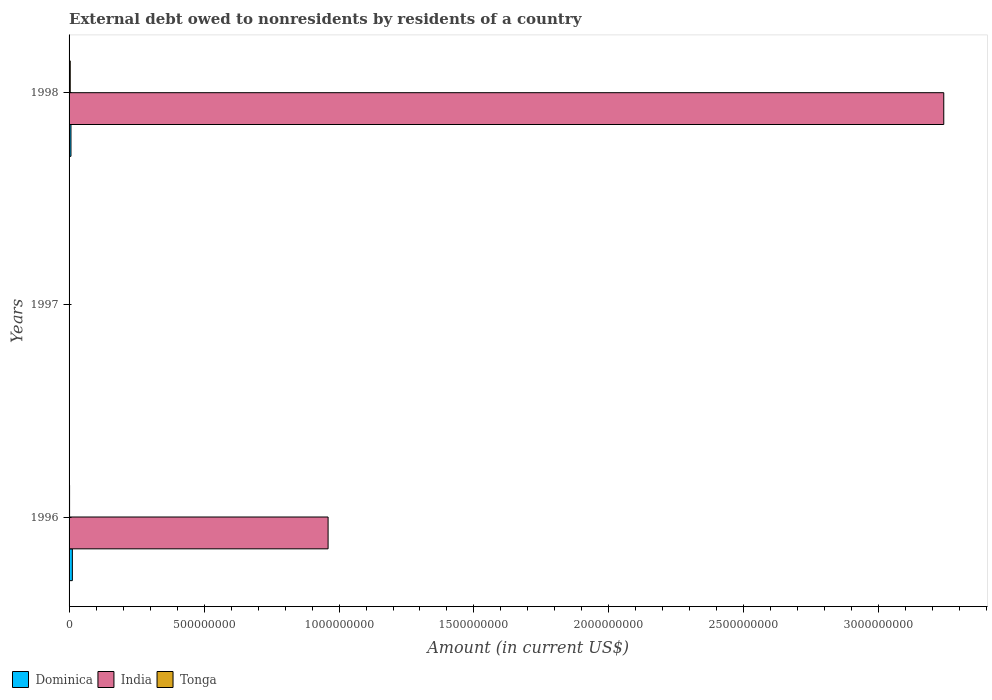How many different coloured bars are there?
Provide a short and direct response. 3. Are the number of bars on each tick of the Y-axis equal?
Provide a succinct answer. No. How many bars are there on the 1st tick from the bottom?
Keep it short and to the point. 3. In how many cases, is the number of bars for a given year not equal to the number of legend labels?
Provide a succinct answer. 1. What is the external debt owed by residents in India in 1996?
Give a very brief answer. 9.60e+08. Across all years, what is the maximum external debt owed by residents in Dominica?
Ensure brevity in your answer.  1.22e+07. Across all years, what is the minimum external debt owed by residents in India?
Provide a succinct answer. 0. In which year was the external debt owed by residents in Tonga maximum?
Ensure brevity in your answer.  1998. What is the total external debt owed by residents in Dominica in the graph?
Offer a terse response. 1.92e+07. What is the difference between the external debt owed by residents in Tonga in 1997 and that in 1998?
Your answer should be compact. -3.48e+06. What is the difference between the external debt owed by residents in Tonga in 1998 and the external debt owed by residents in India in 1997?
Make the answer very short. 4.29e+06. What is the average external debt owed by residents in Dominica per year?
Your response must be concise. 6.41e+06. In the year 1998, what is the difference between the external debt owed by residents in Dominica and external debt owed by residents in Tonga?
Your response must be concise. 2.77e+06. What is the ratio of the external debt owed by residents in Tonga in 1996 to that in 1998?
Provide a succinct answer. 0.43. Is the external debt owed by residents in Tonga in 1996 less than that in 1998?
Give a very brief answer. Yes. What is the difference between the highest and the second highest external debt owed by residents in Tonga?
Provide a short and direct response. 2.42e+06. What is the difference between the highest and the lowest external debt owed by residents in Dominica?
Your answer should be compact. 1.22e+07. In how many years, is the external debt owed by residents in Dominica greater than the average external debt owed by residents in Dominica taken over all years?
Give a very brief answer. 2. Is the sum of the external debt owed by residents in India in 1996 and 1998 greater than the maximum external debt owed by residents in Dominica across all years?
Provide a succinct answer. Yes. Is it the case that in every year, the sum of the external debt owed by residents in Dominica and external debt owed by residents in Tonga is greater than the external debt owed by residents in India?
Give a very brief answer. No. How many years are there in the graph?
Ensure brevity in your answer.  3. What is the difference between two consecutive major ticks on the X-axis?
Your answer should be compact. 5.00e+08. Where does the legend appear in the graph?
Offer a terse response. Bottom left. How many legend labels are there?
Make the answer very short. 3. How are the legend labels stacked?
Offer a very short reply. Horizontal. What is the title of the graph?
Provide a short and direct response. External debt owed to nonresidents by residents of a country. Does "Trinidad and Tobago" appear as one of the legend labels in the graph?
Offer a terse response. No. What is the label or title of the X-axis?
Provide a short and direct response. Amount (in current US$). What is the Amount (in current US$) of Dominica in 1996?
Provide a short and direct response. 1.22e+07. What is the Amount (in current US$) in India in 1996?
Offer a very short reply. 9.60e+08. What is the Amount (in current US$) of Tonga in 1996?
Offer a very short reply. 1.86e+06. What is the Amount (in current US$) of Dominica in 1997?
Offer a terse response. 0. What is the Amount (in current US$) in Tonga in 1997?
Your answer should be very brief. 8.12e+05. What is the Amount (in current US$) in Dominica in 1998?
Ensure brevity in your answer.  7.06e+06. What is the Amount (in current US$) in India in 1998?
Make the answer very short. 3.24e+09. What is the Amount (in current US$) of Tonga in 1998?
Ensure brevity in your answer.  4.29e+06. Across all years, what is the maximum Amount (in current US$) in Dominica?
Keep it short and to the point. 1.22e+07. Across all years, what is the maximum Amount (in current US$) of India?
Offer a terse response. 3.24e+09. Across all years, what is the maximum Amount (in current US$) in Tonga?
Your response must be concise. 4.29e+06. Across all years, what is the minimum Amount (in current US$) in Dominica?
Offer a very short reply. 0. Across all years, what is the minimum Amount (in current US$) of Tonga?
Offer a very short reply. 8.12e+05. What is the total Amount (in current US$) in Dominica in the graph?
Your answer should be compact. 1.92e+07. What is the total Amount (in current US$) in India in the graph?
Provide a succinct answer. 4.20e+09. What is the total Amount (in current US$) in Tonga in the graph?
Offer a terse response. 6.97e+06. What is the difference between the Amount (in current US$) in Tonga in 1996 and that in 1997?
Keep it short and to the point. 1.05e+06. What is the difference between the Amount (in current US$) of Dominica in 1996 and that in 1998?
Give a very brief answer. 5.13e+06. What is the difference between the Amount (in current US$) of India in 1996 and that in 1998?
Your answer should be very brief. -2.28e+09. What is the difference between the Amount (in current US$) of Tonga in 1996 and that in 1998?
Ensure brevity in your answer.  -2.42e+06. What is the difference between the Amount (in current US$) in Tonga in 1997 and that in 1998?
Provide a succinct answer. -3.48e+06. What is the difference between the Amount (in current US$) in Dominica in 1996 and the Amount (in current US$) in Tonga in 1997?
Keep it short and to the point. 1.14e+07. What is the difference between the Amount (in current US$) of India in 1996 and the Amount (in current US$) of Tonga in 1997?
Your answer should be compact. 9.59e+08. What is the difference between the Amount (in current US$) of Dominica in 1996 and the Amount (in current US$) of India in 1998?
Your answer should be compact. -3.23e+09. What is the difference between the Amount (in current US$) of Dominica in 1996 and the Amount (in current US$) of Tonga in 1998?
Provide a succinct answer. 7.90e+06. What is the difference between the Amount (in current US$) of India in 1996 and the Amount (in current US$) of Tonga in 1998?
Offer a terse response. 9.55e+08. What is the average Amount (in current US$) in Dominica per year?
Offer a terse response. 6.41e+06. What is the average Amount (in current US$) of India per year?
Offer a very short reply. 1.40e+09. What is the average Amount (in current US$) of Tonga per year?
Give a very brief answer. 2.32e+06. In the year 1996, what is the difference between the Amount (in current US$) in Dominica and Amount (in current US$) in India?
Give a very brief answer. -9.47e+08. In the year 1996, what is the difference between the Amount (in current US$) of Dominica and Amount (in current US$) of Tonga?
Provide a short and direct response. 1.03e+07. In the year 1996, what is the difference between the Amount (in current US$) in India and Amount (in current US$) in Tonga?
Provide a short and direct response. 9.58e+08. In the year 1998, what is the difference between the Amount (in current US$) of Dominica and Amount (in current US$) of India?
Ensure brevity in your answer.  -3.23e+09. In the year 1998, what is the difference between the Amount (in current US$) of Dominica and Amount (in current US$) of Tonga?
Make the answer very short. 2.77e+06. In the year 1998, what is the difference between the Amount (in current US$) of India and Amount (in current US$) of Tonga?
Your response must be concise. 3.24e+09. What is the ratio of the Amount (in current US$) of Tonga in 1996 to that in 1997?
Provide a short and direct response. 2.3. What is the ratio of the Amount (in current US$) in Dominica in 1996 to that in 1998?
Offer a very short reply. 1.73. What is the ratio of the Amount (in current US$) in India in 1996 to that in 1998?
Ensure brevity in your answer.  0.3. What is the ratio of the Amount (in current US$) in Tonga in 1996 to that in 1998?
Ensure brevity in your answer.  0.43. What is the ratio of the Amount (in current US$) in Tonga in 1997 to that in 1998?
Offer a very short reply. 0.19. What is the difference between the highest and the second highest Amount (in current US$) of Tonga?
Your answer should be compact. 2.42e+06. What is the difference between the highest and the lowest Amount (in current US$) of Dominica?
Offer a very short reply. 1.22e+07. What is the difference between the highest and the lowest Amount (in current US$) of India?
Your answer should be very brief. 3.24e+09. What is the difference between the highest and the lowest Amount (in current US$) in Tonga?
Offer a very short reply. 3.48e+06. 